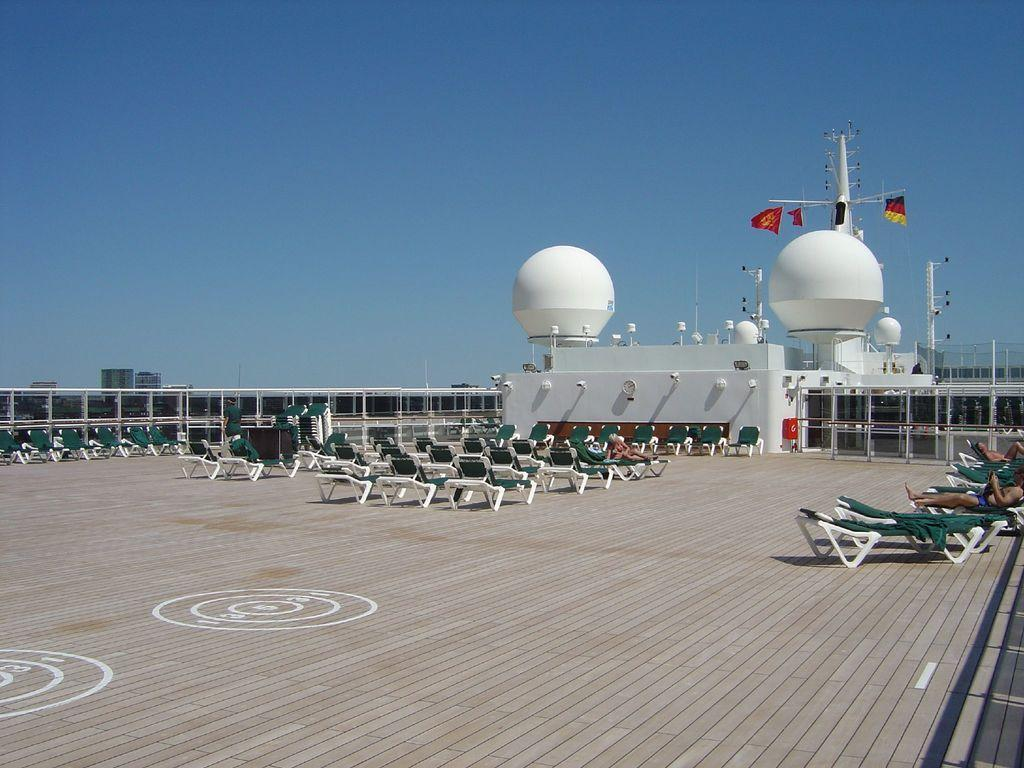What type of furniture is present in the image? There are chairs in the image. What are the people on the chairs doing? There are people lying on the chairs. What color can be seen on some objects in the image? There are white color objects in the image. What can be seen attached to the poles in the image? There are flags in the image. What are the poles used for in the image? The poles are used to hold the flags. What is visible in the background of the image? The sky is blue in the background of the image. What type of hair can be seen on the people in the image? There is no hair visible on the people in the image, as they are lying on the chairs with their faces down. What word is being taught in the image? There is no indication of any teaching or learning activity in the image. 